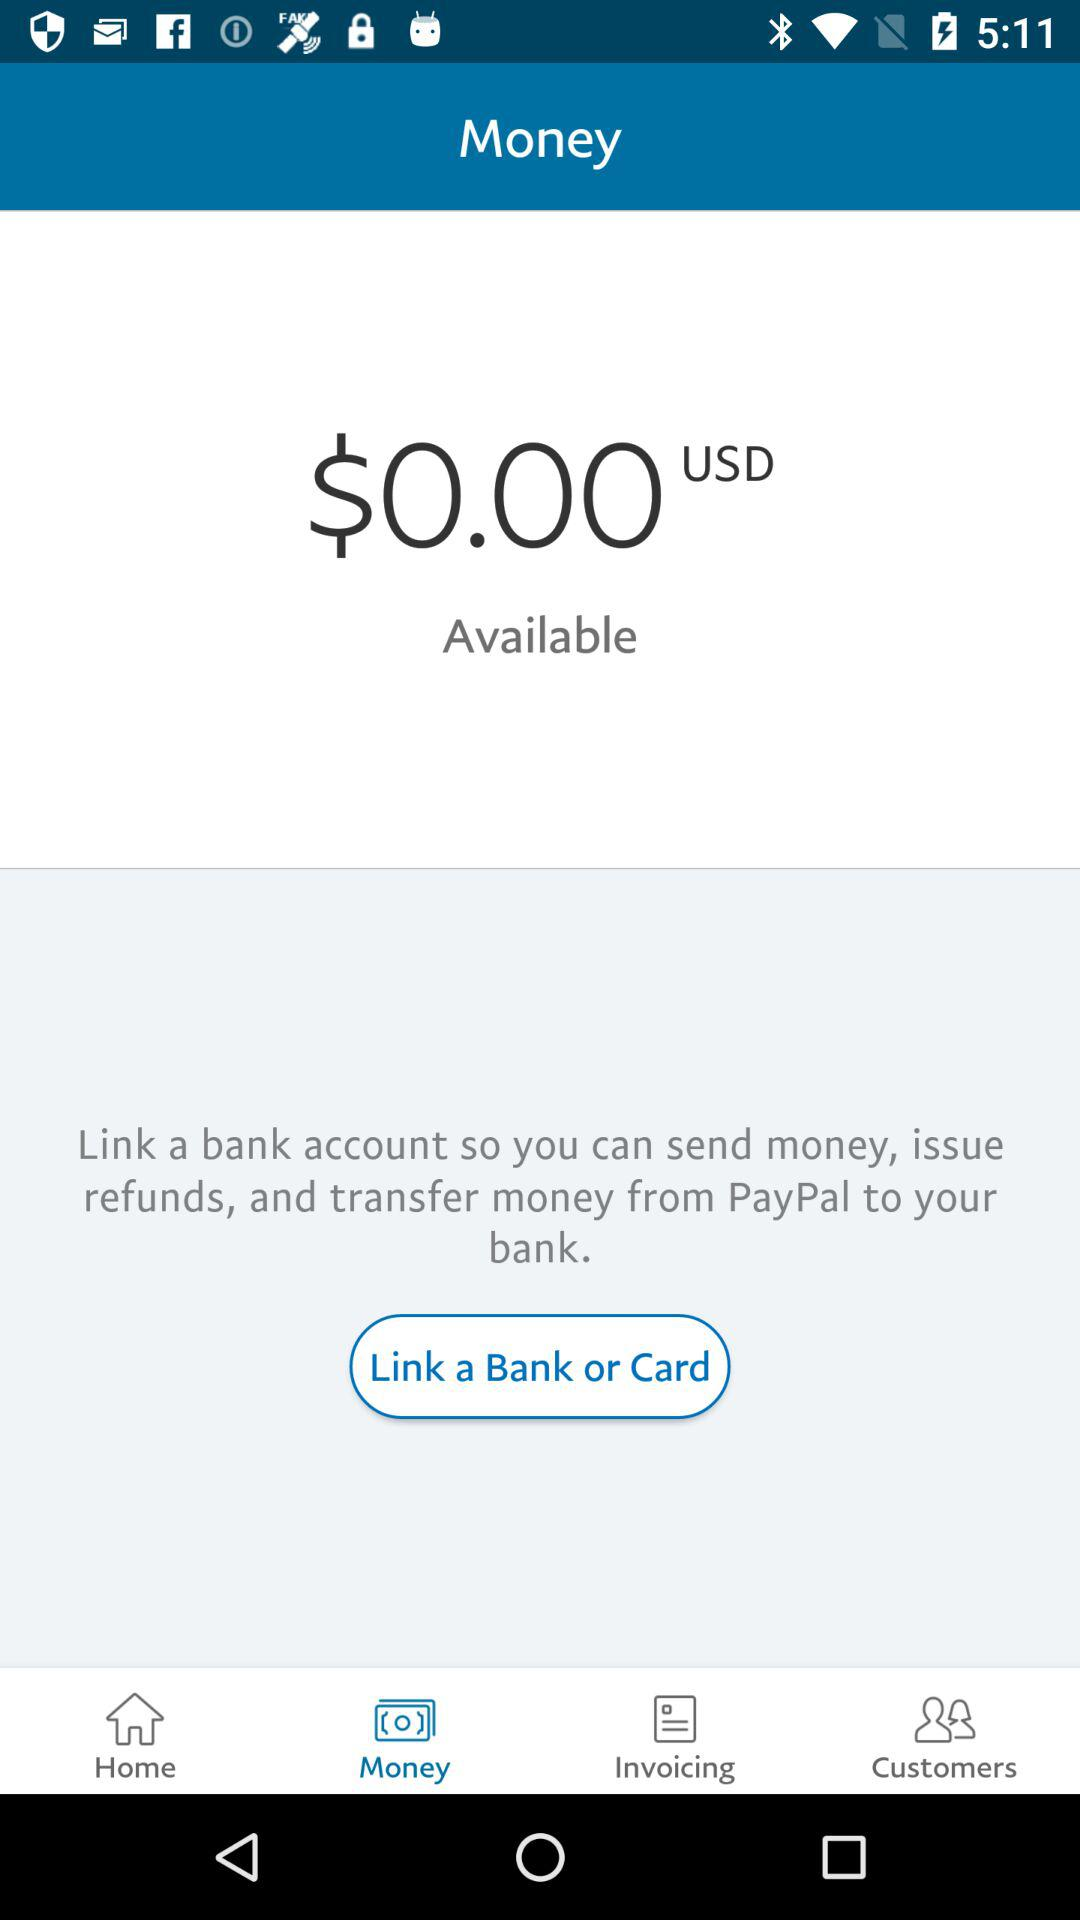What is the selected tab? The selected tab is "Money". 